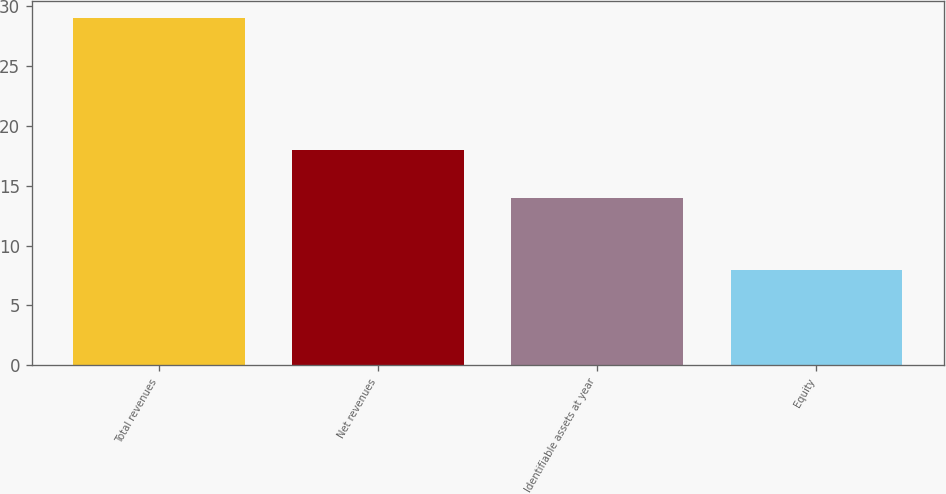Convert chart. <chart><loc_0><loc_0><loc_500><loc_500><bar_chart><fcel>Total revenues<fcel>Net revenues<fcel>Identifiable assets at year<fcel>Equity<nl><fcel>29<fcel>18<fcel>14<fcel>8<nl></chart> 